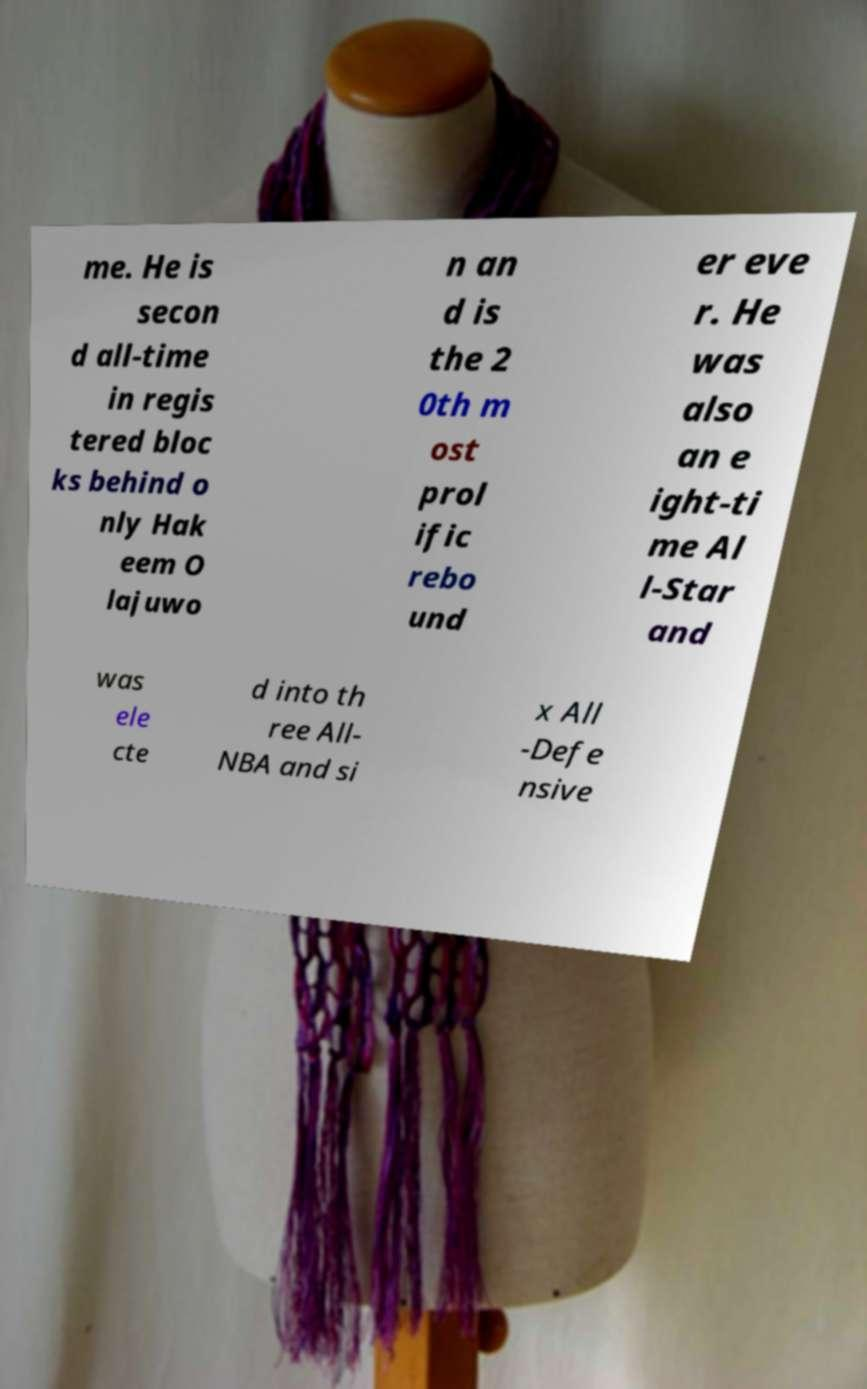I need the written content from this picture converted into text. Can you do that? me. He is secon d all-time in regis tered bloc ks behind o nly Hak eem O lajuwo n an d is the 2 0th m ost prol ific rebo und er eve r. He was also an e ight-ti me Al l-Star and was ele cte d into th ree All- NBA and si x All -Defe nsive 